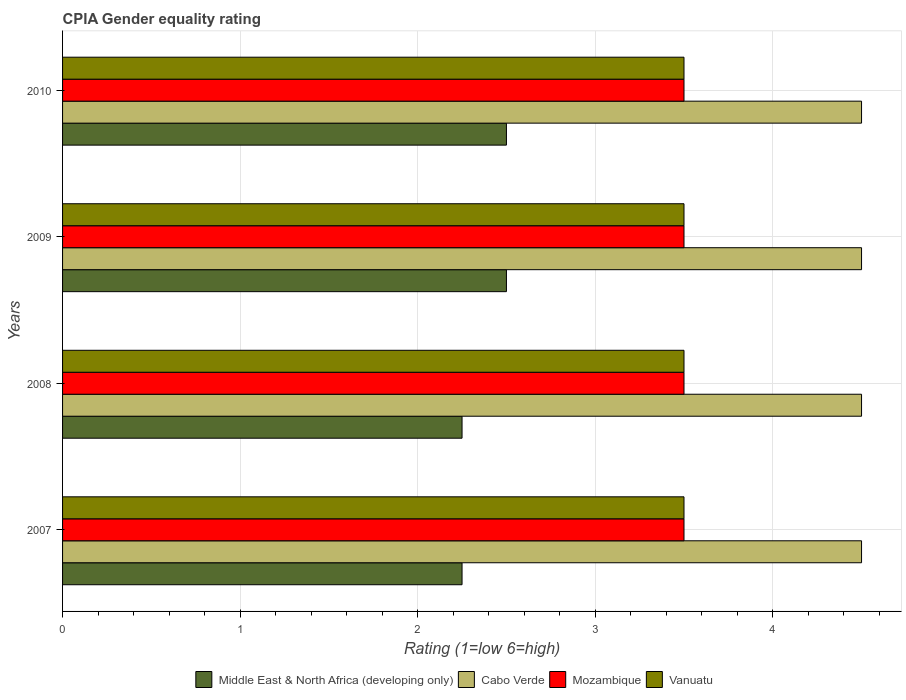Are the number of bars on each tick of the Y-axis equal?
Keep it short and to the point. Yes. How many bars are there on the 2nd tick from the top?
Your response must be concise. 4. In how many cases, is the number of bars for a given year not equal to the number of legend labels?
Provide a short and direct response. 0. Across all years, what is the maximum CPIA rating in Mozambique?
Keep it short and to the point. 3.5. Across all years, what is the minimum CPIA rating in Vanuatu?
Give a very brief answer. 3.5. In how many years, is the CPIA rating in Middle East & North Africa (developing only) greater than 2 ?
Give a very brief answer. 4. What is the ratio of the CPIA rating in Cabo Verde in 2007 to that in 2008?
Your answer should be very brief. 1. Is the CPIA rating in Mozambique in 2008 less than that in 2009?
Make the answer very short. No. What is the difference between the highest and the second highest CPIA rating in Middle East & North Africa (developing only)?
Provide a succinct answer. 0. In how many years, is the CPIA rating in Cabo Verde greater than the average CPIA rating in Cabo Verde taken over all years?
Your answer should be compact. 0. Is the sum of the CPIA rating in Vanuatu in 2007 and 2008 greater than the maximum CPIA rating in Cabo Verde across all years?
Keep it short and to the point. Yes. What does the 2nd bar from the top in 2010 represents?
Provide a succinct answer. Mozambique. What does the 1st bar from the bottom in 2007 represents?
Offer a terse response. Middle East & North Africa (developing only). Is it the case that in every year, the sum of the CPIA rating in Vanuatu and CPIA rating in Middle East & North Africa (developing only) is greater than the CPIA rating in Cabo Verde?
Offer a terse response. Yes. Are all the bars in the graph horizontal?
Your answer should be very brief. Yes. How many years are there in the graph?
Give a very brief answer. 4. What is the difference between two consecutive major ticks on the X-axis?
Offer a terse response. 1. Are the values on the major ticks of X-axis written in scientific E-notation?
Offer a terse response. No. Does the graph contain grids?
Make the answer very short. Yes. Where does the legend appear in the graph?
Make the answer very short. Bottom center. What is the title of the graph?
Your response must be concise. CPIA Gender equality rating. What is the label or title of the X-axis?
Keep it short and to the point. Rating (1=low 6=high). What is the Rating (1=low 6=high) of Middle East & North Africa (developing only) in 2007?
Provide a short and direct response. 2.25. What is the Rating (1=low 6=high) in Mozambique in 2007?
Ensure brevity in your answer.  3.5. What is the Rating (1=low 6=high) in Vanuatu in 2007?
Give a very brief answer. 3.5. What is the Rating (1=low 6=high) in Middle East & North Africa (developing only) in 2008?
Offer a very short reply. 2.25. What is the Rating (1=low 6=high) of Cabo Verde in 2008?
Make the answer very short. 4.5. What is the Rating (1=low 6=high) of Mozambique in 2008?
Give a very brief answer. 3.5. What is the Rating (1=low 6=high) of Cabo Verde in 2009?
Your answer should be compact. 4.5. What is the Rating (1=low 6=high) of Mozambique in 2009?
Ensure brevity in your answer.  3.5. What is the Rating (1=low 6=high) in Cabo Verde in 2010?
Offer a very short reply. 4.5. What is the Rating (1=low 6=high) in Vanuatu in 2010?
Keep it short and to the point. 3.5. Across all years, what is the maximum Rating (1=low 6=high) in Middle East & North Africa (developing only)?
Make the answer very short. 2.5. Across all years, what is the maximum Rating (1=low 6=high) in Cabo Verde?
Provide a short and direct response. 4.5. Across all years, what is the maximum Rating (1=low 6=high) in Mozambique?
Keep it short and to the point. 3.5. Across all years, what is the maximum Rating (1=low 6=high) in Vanuatu?
Make the answer very short. 3.5. Across all years, what is the minimum Rating (1=low 6=high) in Middle East & North Africa (developing only)?
Ensure brevity in your answer.  2.25. What is the total Rating (1=low 6=high) of Middle East & North Africa (developing only) in the graph?
Ensure brevity in your answer.  9.5. What is the total Rating (1=low 6=high) of Vanuatu in the graph?
Your response must be concise. 14. What is the difference between the Rating (1=low 6=high) of Cabo Verde in 2007 and that in 2008?
Keep it short and to the point. 0. What is the difference between the Rating (1=low 6=high) in Mozambique in 2007 and that in 2008?
Make the answer very short. 0. What is the difference between the Rating (1=low 6=high) of Vanuatu in 2007 and that in 2008?
Ensure brevity in your answer.  0. What is the difference between the Rating (1=low 6=high) of Middle East & North Africa (developing only) in 2007 and that in 2009?
Make the answer very short. -0.25. What is the difference between the Rating (1=low 6=high) in Cabo Verde in 2007 and that in 2009?
Provide a succinct answer. 0. What is the difference between the Rating (1=low 6=high) of Vanuatu in 2007 and that in 2010?
Keep it short and to the point. 0. What is the difference between the Rating (1=low 6=high) of Vanuatu in 2008 and that in 2009?
Offer a terse response. 0. What is the difference between the Rating (1=low 6=high) of Middle East & North Africa (developing only) in 2008 and that in 2010?
Your answer should be very brief. -0.25. What is the difference between the Rating (1=low 6=high) of Mozambique in 2008 and that in 2010?
Make the answer very short. 0. What is the difference between the Rating (1=low 6=high) in Vanuatu in 2008 and that in 2010?
Your response must be concise. 0. What is the difference between the Rating (1=low 6=high) of Mozambique in 2009 and that in 2010?
Your response must be concise. 0. What is the difference between the Rating (1=low 6=high) in Vanuatu in 2009 and that in 2010?
Ensure brevity in your answer.  0. What is the difference between the Rating (1=low 6=high) of Middle East & North Africa (developing only) in 2007 and the Rating (1=low 6=high) of Cabo Verde in 2008?
Provide a short and direct response. -2.25. What is the difference between the Rating (1=low 6=high) in Middle East & North Africa (developing only) in 2007 and the Rating (1=low 6=high) in Mozambique in 2008?
Ensure brevity in your answer.  -1.25. What is the difference between the Rating (1=low 6=high) of Middle East & North Africa (developing only) in 2007 and the Rating (1=low 6=high) of Vanuatu in 2008?
Keep it short and to the point. -1.25. What is the difference between the Rating (1=low 6=high) in Mozambique in 2007 and the Rating (1=low 6=high) in Vanuatu in 2008?
Your answer should be compact. 0. What is the difference between the Rating (1=low 6=high) of Middle East & North Africa (developing only) in 2007 and the Rating (1=low 6=high) of Cabo Verde in 2009?
Provide a short and direct response. -2.25. What is the difference between the Rating (1=low 6=high) in Middle East & North Africa (developing only) in 2007 and the Rating (1=low 6=high) in Mozambique in 2009?
Offer a very short reply. -1.25. What is the difference between the Rating (1=low 6=high) in Middle East & North Africa (developing only) in 2007 and the Rating (1=low 6=high) in Vanuatu in 2009?
Make the answer very short. -1.25. What is the difference between the Rating (1=low 6=high) in Mozambique in 2007 and the Rating (1=low 6=high) in Vanuatu in 2009?
Provide a succinct answer. 0. What is the difference between the Rating (1=low 6=high) of Middle East & North Africa (developing only) in 2007 and the Rating (1=low 6=high) of Cabo Verde in 2010?
Keep it short and to the point. -2.25. What is the difference between the Rating (1=low 6=high) of Middle East & North Africa (developing only) in 2007 and the Rating (1=low 6=high) of Mozambique in 2010?
Give a very brief answer. -1.25. What is the difference between the Rating (1=low 6=high) in Middle East & North Africa (developing only) in 2007 and the Rating (1=low 6=high) in Vanuatu in 2010?
Offer a terse response. -1.25. What is the difference between the Rating (1=low 6=high) of Cabo Verde in 2007 and the Rating (1=low 6=high) of Vanuatu in 2010?
Provide a short and direct response. 1. What is the difference between the Rating (1=low 6=high) of Middle East & North Africa (developing only) in 2008 and the Rating (1=low 6=high) of Cabo Verde in 2009?
Provide a short and direct response. -2.25. What is the difference between the Rating (1=low 6=high) of Middle East & North Africa (developing only) in 2008 and the Rating (1=low 6=high) of Mozambique in 2009?
Your answer should be compact. -1.25. What is the difference between the Rating (1=low 6=high) of Middle East & North Africa (developing only) in 2008 and the Rating (1=low 6=high) of Vanuatu in 2009?
Make the answer very short. -1.25. What is the difference between the Rating (1=low 6=high) in Cabo Verde in 2008 and the Rating (1=low 6=high) in Vanuatu in 2009?
Your answer should be very brief. 1. What is the difference between the Rating (1=low 6=high) of Middle East & North Africa (developing only) in 2008 and the Rating (1=low 6=high) of Cabo Verde in 2010?
Provide a succinct answer. -2.25. What is the difference between the Rating (1=low 6=high) in Middle East & North Africa (developing only) in 2008 and the Rating (1=low 6=high) in Mozambique in 2010?
Your response must be concise. -1.25. What is the difference between the Rating (1=low 6=high) of Middle East & North Africa (developing only) in 2008 and the Rating (1=low 6=high) of Vanuatu in 2010?
Make the answer very short. -1.25. What is the difference between the Rating (1=low 6=high) in Mozambique in 2008 and the Rating (1=low 6=high) in Vanuatu in 2010?
Provide a succinct answer. 0. What is the difference between the Rating (1=low 6=high) in Middle East & North Africa (developing only) in 2009 and the Rating (1=low 6=high) in Vanuatu in 2010?
Your answer should be compact. -1. What is the difference between the Rating (1=low 6=high) of Cabo Verde in 2009 and the Rating (1=low 6=high) of Mozambique in 2010?
Provide a short and direct response. 1. What is the average Rating (1=low 6=high) in Middle East & North Africa (developing only) per year?
Offer a very short reply. 2.38. What is the average Rating (1=low 6=high) in Cabo Verde per year?
Your answer should be compact. 4.5. In the year 2007, what is the difference between the Rating (1=low 6=high) in Middle East & North Africa (developing only) and Rating (1=low 6=high) in Cabo Verde?
Your response must be concise. -2.25. In the year 2007, what is the difference between the Rating (1=low 6=high) in Middle East & North Africa (developing only) and Rating (1=low 6=high) in Mozambique?
Your answer should be compact. -1.25. In the year 2007, what is the difference between the Rating (1=low 6=high) of Middle East & North Africa (developing only) and Rating (1=low 6=high) of Vanuatu?
Give a very brief answer. -1.25. In the year 2007, what is the difference between the Rating (1=low 6=high) in Cabo Verde and Rating (1=low 6=high) in Mozambique?
Give a very brief answer. 1. In the year 2007, what is the difference between the Rating (1=low 6=high) of Cabo Verde and Rating (1=low 6=high) of Vanuatu?
Your answer should be very brief. 1. In the year 2008, what is the difference between the Rating (1=low 6=high) of Middle East & North Africa (developing only) and Rating (1=low 6=high) of Cabo Verde?
Ensure brevity in your answer.  -2.25. In the year 2008, what is the difference between the Rating (1=low 6=high) in Middle East & North Africa (developing only) and Rating (1=low 6=high) in Mozambique?
Offer a terse response. -1.25. In the year 2008, what is the difference between the Rating (1=low 6=high) in Middle East & North Africa (developing only) and Rating (1=low 6=high) in Vanuatu?
Keep it short and to the point. -1.25. In the year 2009, what is the difference between the Rating (1=low 6=high) in Middle East & North Africa (developing only) and Rating (1=low 6=high) in Cabo Verde?
Provide a short and direct response. -2. In the year 2009, what is the difference between the Rating (1=low 6=high) in Middle East & North Africa (developing only) and Rating (1=low 6=high) in Mozambique?
Give a very brief answer. -1. In the year 2009, what is the difference between the Rating (1=low 6=high) of Cabo Verde and Rating (1=low 6=high) of Vanuatu?
Your answer should be very brief. 1. In the year 2010, what is the difference between the Rating (1=low 6=high) of Middle East & North Africa (developing only) and Rating (1=low 6=high) of Cabo Verde?
Offer a terse response. -2. In the year 2010, what is the difference between the Rating (1=low 6=high) of Middle East & North Africa (developing only) and Rating (1=low 6=high) of Mozambique?
Provide a short and direct response. -1. In the year 2010, what is the difference between the Rating (1=low 6=high) of Cabo Verde and Rating (1=low 6=high) of Mozambique?
Your answer should be very brief. 1. In the year 2010, what is the difference between the Rating (1=low 6=high) of Cabo Verde and Rating (1=low 6=high) of Vanuatu?
Your answer should be very brief. 1. What is the ratio of the Rating (1=low 6=high) in Middle East & North Africa (developing only) in 2007 to that in 2008?
Ensure brevity in your answer.  1. What is the ratio of the Rating (1=low 6=high) in Mozambique in 2007 to that in 2009?
Make the answer very short. 1. What is the ratio of the Rating (1=low 6=high) of Middle East & North Africa (developing only) in 2007 to that in 2010?
Keep it short and to the point. 0.9. What is the ratio of the Rating (1=low 6=high) of Mozambique in 2007 to that in 2010?
Offer a terse response. 1. What is the ratio of the Rating (1=low 6=high) of Vanuatu in 2007 to that in 2010?
Provide a succinct answer. 1. What is the ratio of the Rating (1=low 6=high) of Middle East & North Africa (developing only) in 2008 to that in 2009?
Your response must be concise. 0.9. What is the ratio of the Rating (1=low 6=high) in Cabo Verde in 2008 to that in 2010?
Keep it short and to the point. 1. What is the ratio of the Rating (1=low 6=high) of Mozambique in 2008 to that in 2010?
Ensure brevity in your answer.  1. What is the ratio of the Rating (1=low 6=high) in Vanuatu in 2008 to that in 2010?
Your answer should be very brief. 1. What is the ratio of the Rating (1=low 6=high) in Middle East & North Africa (developing only) in 2009 to that in 2010?
Give a very brief answer. 1. What is the ratio of the Rating (1=low 6=high) in Mozambique in 2009 to that in 2010?
Provide a short and direct response. 1. What is the ratio of the Rating (1=low 6=high) in Vanuatu in 2009 to that in 2010?
Offer a very short reply. 1. What is the difference between the highest and the second highest Rating (1=low 6=high) of Middle East & North Africa (developing only)?
Your answer should be compact. 0. What is the difference between the highest and the second highest Rating (1=low 6=high) in Cabo Verde?
Offer a terse response. 0. What is the difference between the highest and the second highest Rating (1=low 6=high) in Mozambique?
Ensure brevity in your answer.  0. What is the difference between the highest and the lowest Rating (1=low 6=high) in Cabo Verde?
Keep it short and to the point. 0. What is the difference between the highest and the lowest Rating (1=low 6=high) of Vanuatu?
Give a very brief answer. 0. 